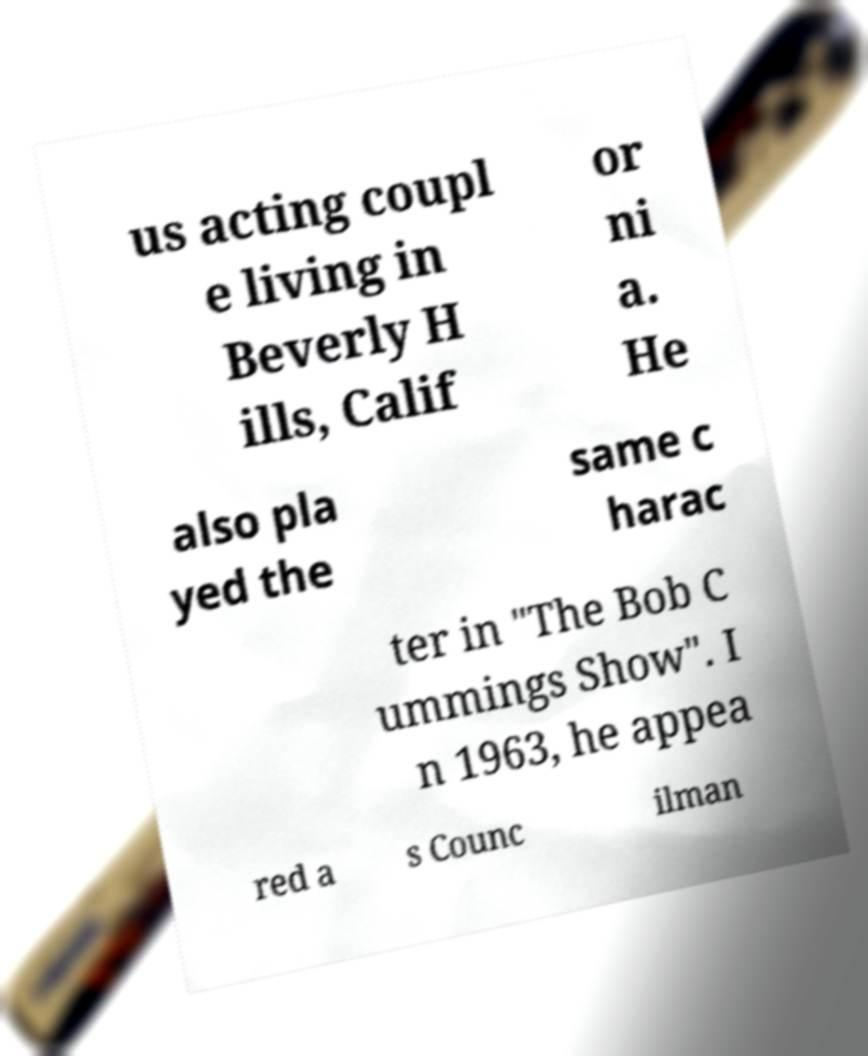Please read and relay the text visible in this image. What does it say? us acting coupl e living in Beverly H ills, Calif or ni a. He also pla yed the same c harac ter in "The Bob C ummings Show". I n 1963, he appea red a s Counc ilman 